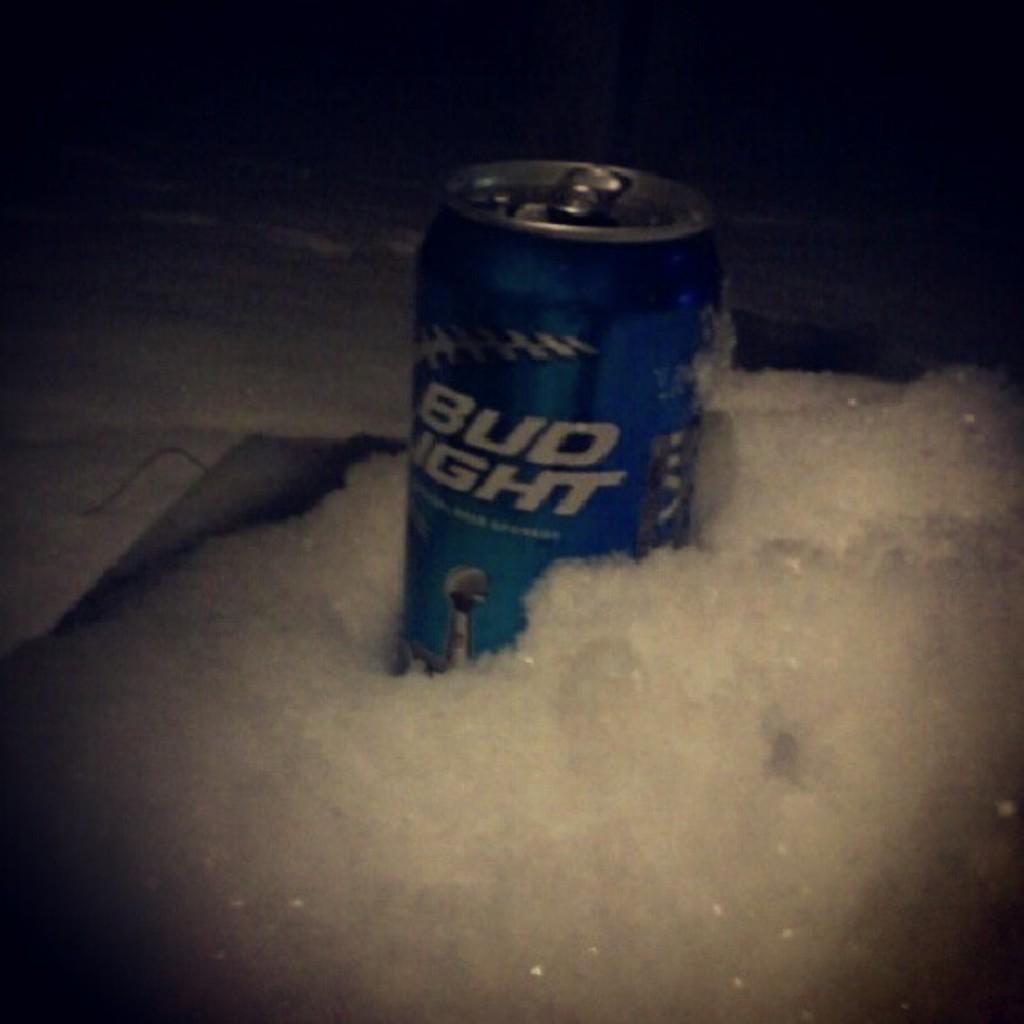<image>
Relay a brief, clear account of the picture shown. A can of Bud Light is sitting in the snow. 